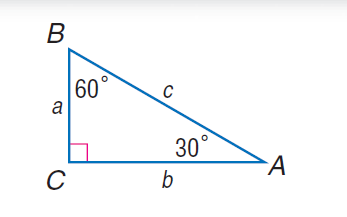Answer the mathemtical geometry problem and directly provide the correct option letter.
Question: If b = 3, find c.
Choices: A: \sqrt { 3 } B: \sqrt { 5 } C: \sqrt { 7 } D: 2 \sqrt { 3 } D 